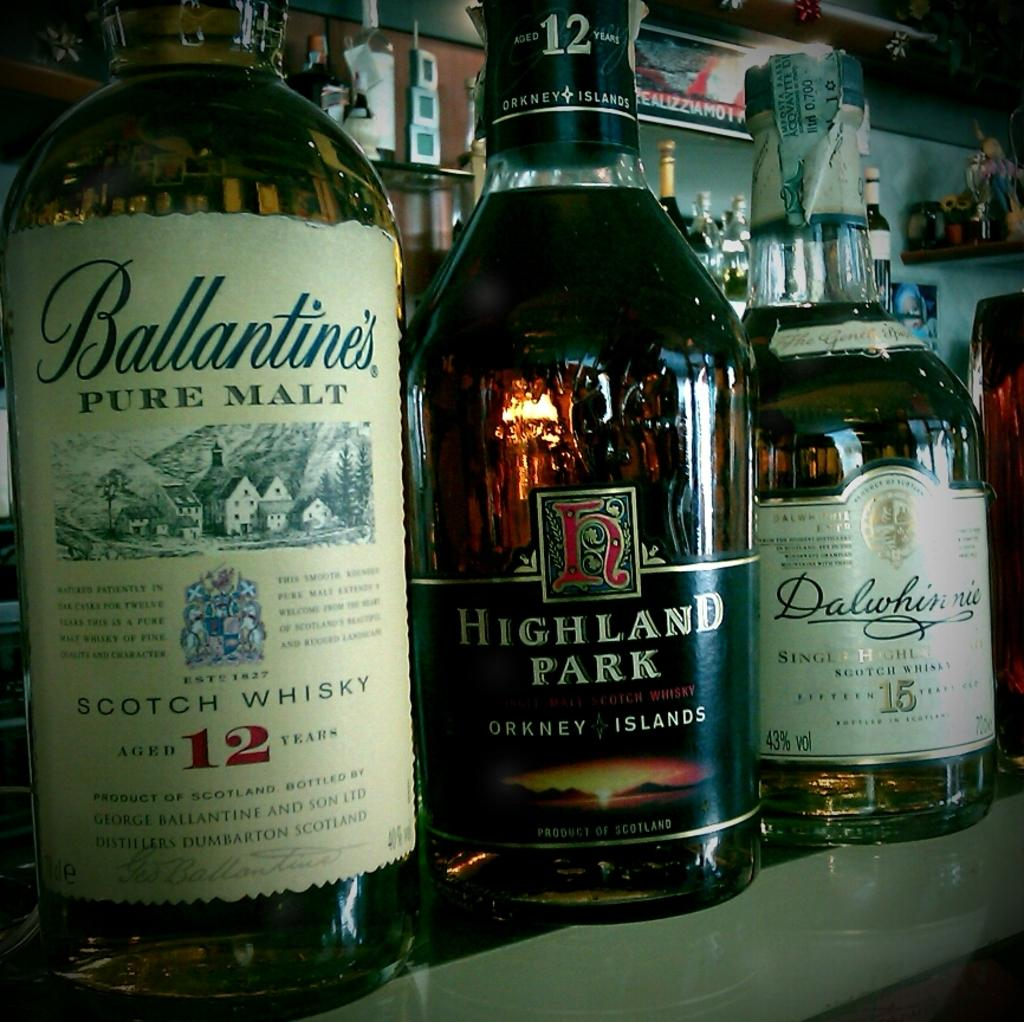Provide a one-sentence caption for the provided image. A row of whisky bottles by Highland Park and Ballantines sitting on a bar shelf. 